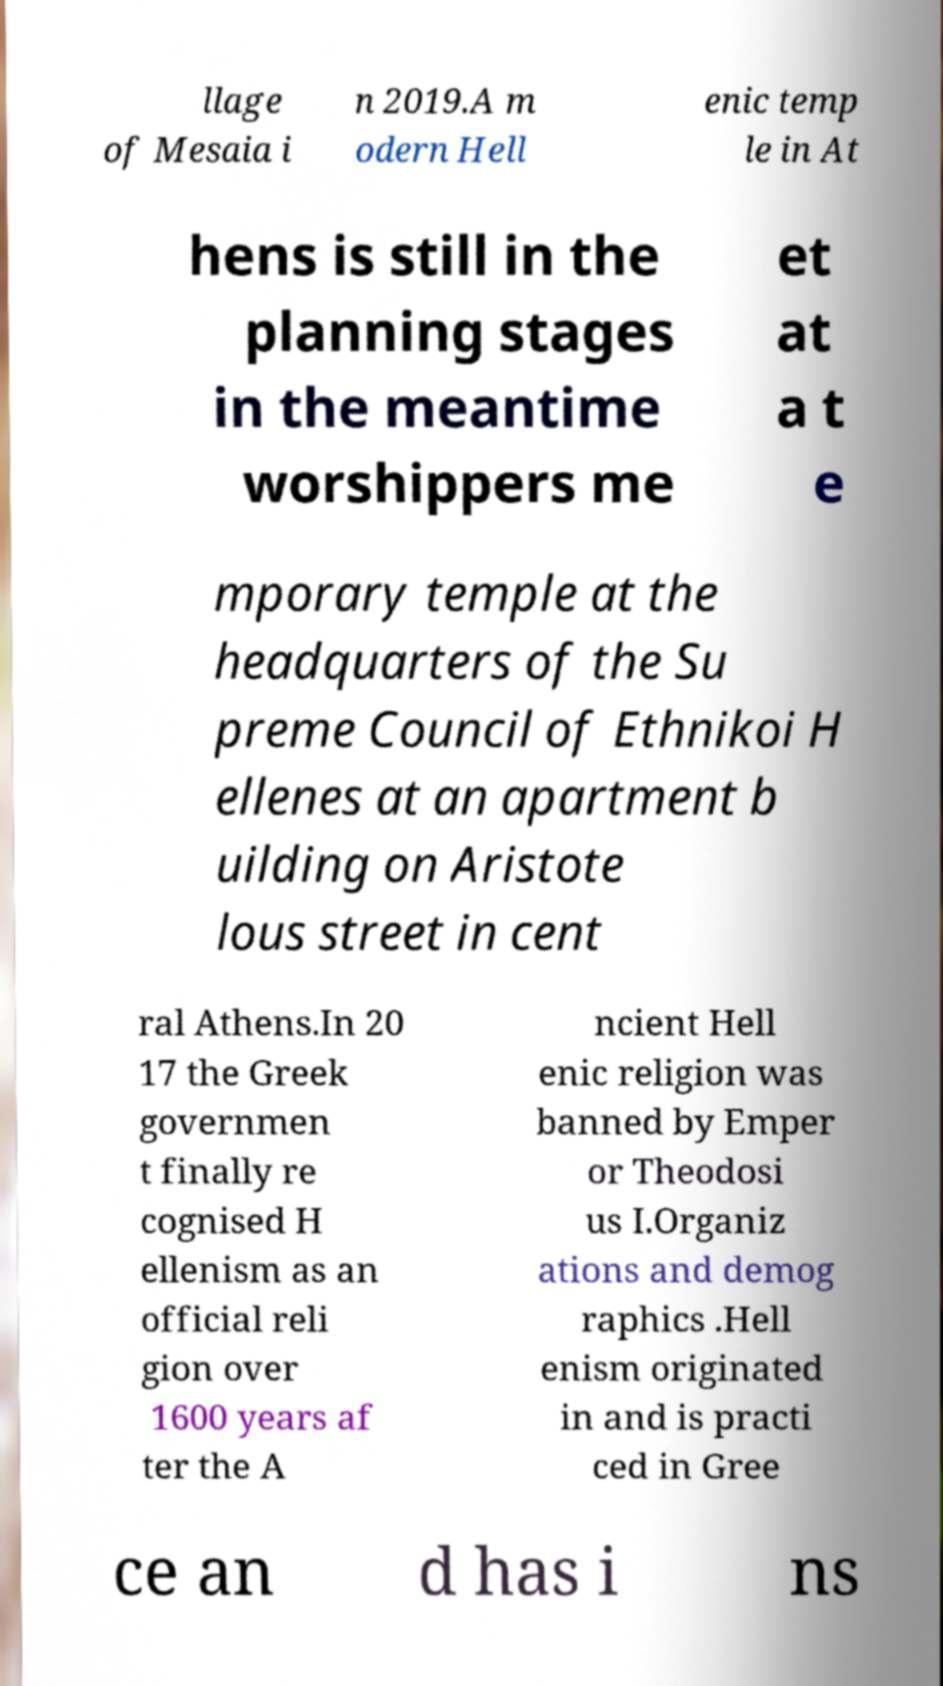Can you read and provide the text displayed in the image?This photo seems to have some interesting text. Can you extract and type it out for me? llage of Mesaia i n 2019.A m odern Hell enic temp le in At hens is still in the planning stages in the meantime worshippers me et at a t e mporary temple at the headquarters of the Su preme Council of Ethnikoi H ellenes at an apartment b uilding on Aristote lous street in cent ral Athens.In 20 17 the Greek governmen t finally re cognised H ellenism as an official reli gion over 1600 years af ter the A ncient Hell enic religion was banned by Emper or Theodosi us I.Organiz ations and demog raphics .Hell enism originated in and is practi ced in Gree ce an d has i ns 